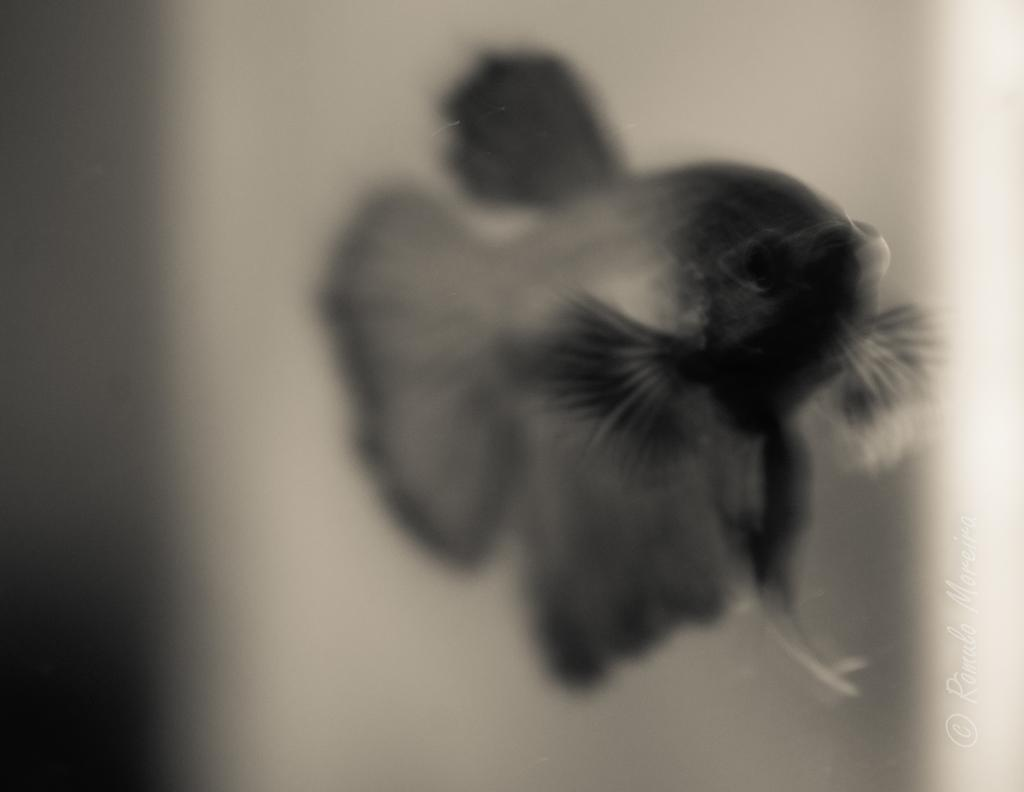What is the color scheme of the image? The image is black and white. What animal is present in the image? There is a fish in the image. In which direction is the fish facing? The fish is facing towards the right side. Can you describe the background of the image? The background of the image is blurred. What type of band is playing in the background of the image? There is no band present in the image; it is a black and white image of a fish. Can you tell me when the fish was born from the image? The image does not provide information about the fish's birth, as it only shows the fish's current position and direction. 